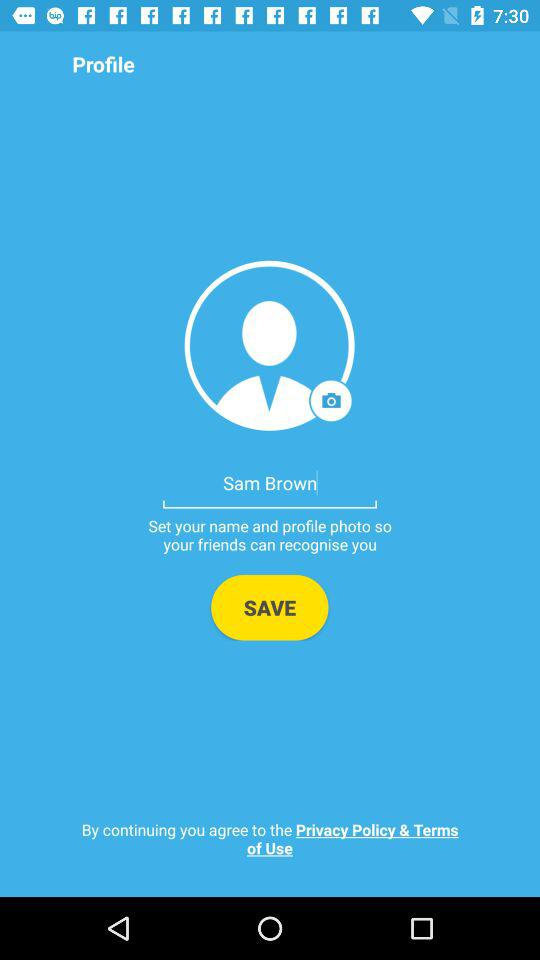What is the user name? The user name is Sam Brown. 